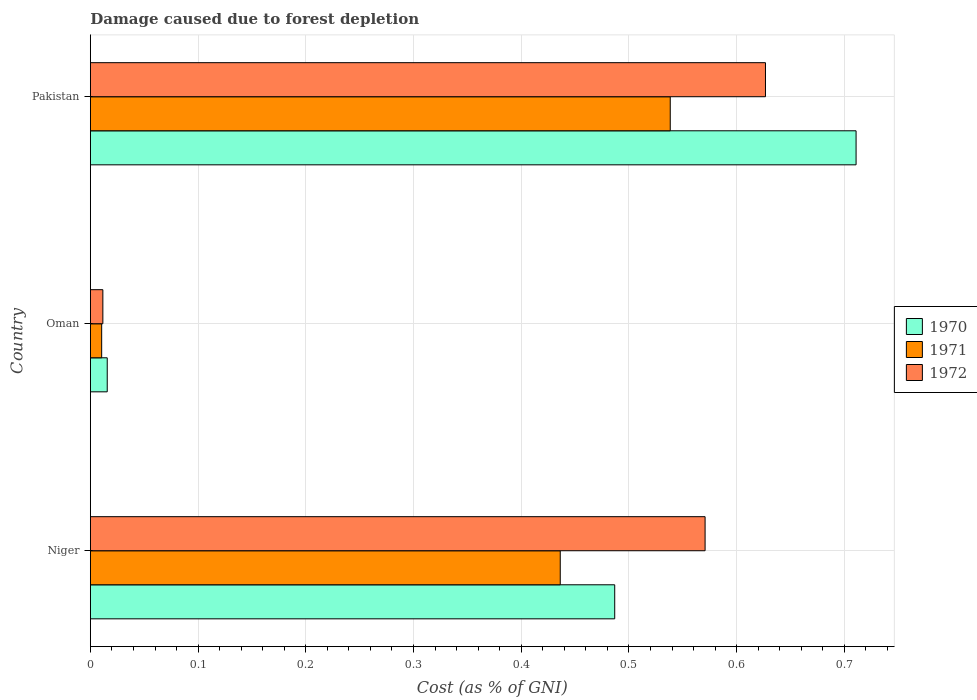Are the number of bars per tick equal to the number of legend labels?
Your answer should be compact. Yes. Are the number of bars on each tick of the Y-axis equal?
Provide a short and direct response. Yes. How many bars are there on the 2nd tick from the top?
Offer a terse response. 3. How many bars are there on the 1st tick from the bottom?
Keep it short and to the point. 3. What is the label of the 3rd group of bars from the top?
Your response must be concise. Niger. What is the cost of damage caused due to forest depletion in 1970 in Oman?
Keep it short and to the point. 0.02. Across all countries, what is the maximum cost of damage caused due to forest depletion in 1971?
Provide a short and direct response. 0.54. Across all countries, what is the minimum cost of damage caused due to forest depletion in 1970?
Ensure brevity in your answer.  0.02. In which country was the cost of damage caused due to forest depletion in 1970 maximum?
Give a very brief answer. Pakistan. In which country was the cost of damage caused due to forest depletion in 1972 minimum?
Offer a very short reply. Oman. What is the total cost of damage caused due to forest depletion in 1972 in the graph?
Provide a short and direct response. 1.21. What is the difference between the cost of damage caused due to forest depletion in 1970 in Niger and that in Oman?
Your answer should be very brief. 0.47. What is the difference between the cost of damage caused due to forest depletion in 1971 in Niger and the cost of damage caused due to forest depletion in 1972 in Oman?
Your response must be concise. 0.42. What is the average cost of damage caused due to forest depletion in 1971 per country?
Offer a very short reply. 0.33. What is the difference between the cost of damage caused due to forest depletion in 1970 and cost of damage caused due to forest depletion in 1972 in Niger?
Your answer should be very brief. -0.08. What is the ratio of the cost of damage caused due to forest depletion in 1970 in Niger to that in Oman?
Offer a terse response. 31.07. What is the difference between the highest and the second highest cost of damage caused due to forest depletion in 1971?
Your answer should be very brief. 0.1. What is the difference between the highest and the lowest cost of damage caused due to forest depletion in 1972?
Make the answer very short. 0.62. Is the sum of the cost of damage caused due to forest depletion in 1970 in Niger and Pakistan greater than the maximum cost of damage caused due to forest depletion in 1972 across all countries?
Provide a short and direct response. Yes. What does the 3rd bar from the top in Niger represents?
Provide a succinct answer. 1970. How many bars are there?
Offer a terse response. 9. What is the difference between two consecutive major ticks on the X-axis?
Keep it short and to the point. 0.1. Are the values on the major ticks of X-axis written in scientific E-notation?
Make the answer very short. No. Where does the legend appear in the graph?
Make the answer very short. Center right. How are the legend labels stacked?
Make the answer very short. Vertical. What is the title of the graph?
Provide a short and direct response. Damage caused due to forest depletion. Does "1961" appear as one of the legend labels in the graph?
Give a very brief answer. No. What is the label or title of the X-axis?
Your answer should be very brief. Cost (as % of GNI). What is the label or title of the Y-axis?
Give a very brief answer. Country. What is the Cost (as % of GNI) of 1970 in Niger?
Ensure brevity in your answer.  0.49. What is the Cost (as % of GNI) in 1971 in Niger?
Provide a short and direct response. 0.44. What is the Cost (as % of GNI) in 1972 in Niger?
Ensure brevity in your answer.  0.57. What is the Cost (as % of GNI) of 1970 in Oman?
Ensure brevity in your answer.  0.02. What is the Cost (as % of GNI) of 1971 in Oman?
Your response must be concise. 0.01. What is the Cost (as % of GNI) of 1972 in Oman?
Give a very brief answer. 0.01. What is the Cost (as % of GNI) in 1970 in Pakistan?
Make the answer very short. 0.71. What is the Cost (as % of GNI) in 1971 in Pakistan?
Provide a succinct answer. 0.54. What is the Cost (as % of GNI) of 1972 in Pakistan?
Offer a very short reply. 0.63. Across all countries, what is the maximum Cost (as % of GNI) in 1970?
Keep it short and to the point. 0.71. Across all countries, what is the maximum Cost (as % of GNI) in 1971?
Make the answer very short. 0.54. Across all countries, what is the maximum Cost (as % of GNI) in 1972?
Provide a succinct answer. 0.63. Across all countries, what is the minimum Cost (as % of GNI) in 1970?
Offer a very short reply. 0.02. Across all countries, what is the minimum Cost (as % of GNI) of 1971?
Ensure brevity in your answer.  0.01. Across all countries, what is the minimum Cost (as % of GNI) of 1972?
Offer a very short reply. 0.01. What is the total Cost (as % of GNI) of 1970 in the graph?
Your answer should be very brief. 1.21. What is the total Cost (as % of GNI) of 1972 in the graph?
Ensure brevity in your answer.  1.21. What is the difference between the Cost (as % of GNI) of 1970 in Niger and that in Oman?
Provide a succinct answer. 0.47. What is the difference between the Cost (as % of GNI) of 1971 in Niger and that in Oman?
Your response must be concise. 0.43. What is the difference between the Cost (as % of GNI) in 1972 in Niger and that in Oman?
Make the answer very short. 0.56. What is the difference between the Cost (as % of GNI) of 1970 in Niger and that in Pakistan?
Your answer should be very brief. -0.22. What is the difference between the Cost (as % of GNI) of 1971 in Niger and that in Pakistan?
Give a very brief answer. -0.1. What is the difference between the Cost (as % of GNI) of 1972 in Niger and that in Pakistan?
Ensure brevity in your answer.  -0.06. What is the difference between the Cost (as % of GNI) in 1970 in Oman and that in Pakistan?
Provide a succinct answer. -0.7. What is the difference between the Cost (as % of GNI) of 1971 in Oman and that in Pakistan?
Ensure brevity in your answer.  -0.53. What is the difference between the Cost (as % of GNI) in 1972 in Oman and that in Pakistan?
Offer a very short reply. -0.62. What is the difference between the Cost (as % of GNI) in 1970 in Niger and the Cost (as % of GNI) in 1971 in Oman?
Provide a succinct answer. 0.48. What is the difference between the Cost (as % of GNI) of 1970 in Niger and the Cost (as % of GNI) of 1972 in Oman?
Ensure brevity in your answer.  0.48. What is the difference between the Cost (as % of GNI) of 1971 in Niger and the Cost (as % of GNI) of 1972 in Oman?
Your answer should be very brief. 0.42. What is the difference between the Cost (as % of GNI) in 1970 in Niger and the Cost (as % of GNI) in 1971 in Pakistan?
Give a very brief answer. -0.05. What is the difference between the Cost (as % of GNI) in 1970 in Niger and the Cost (as % of GNI) in 1972 in Pakistan?
Your answer should be compact. -0.14. What is the difference between the Cost (as % of GNI) of 1971 in Niger and the Cost (as % of GNI) of 1972 in Pakistan?
Offer a very short reply. -0.19. What is the difference between the Cost (as % of GNI) in 1970 in Oman and the Cost (as % of GNI) in 1971 in Pakistan?
Provide a short and direct response. -0.52. What is the difference between the Cost (as % of GNI) of 1970 in Oman and the Cost (as % of GNI) of 1972 in Pakistan?
Provide a succinct answer. -0.61. What is the difference between the Cost (as % of GNI) in 1971 in Oman and the Cost (as % of GNI) in 1972 in Pakistan?
Give a very brief answer. -0.62. What is the average Cost (as % of GNI) in 1970 per country?
Your answer should be compact. 0.4. What is the average Cost (as % of GNI) of 1971 per country?
Provide a succinct answer. 0.33. What is the average Cost (as % of GNI) of 1972 per country?
Offer a very short reply. 0.4. What is the difference between the Cost (as % of GNI) of 1970 and Cost (as % of GNI) of 1971 in Niger?
Keep it short and to the point. 0.05. What is the difference between the Cost (as % of GNI) of 1970 and Cost (as % of GNI) of 1972 in Niger?
Offer a very short reply. -0.08. What is the difference between the Cost (as % of GNI) in 1971 and Cost (as % of GNI) in 1972 in Niger?
Keep it short and to the point. -0.13. What is the difference between the Cost (as % of GNI) in 1970 and Cost (as % of GNI) in 1971 in Oman?
Provide a succinct answer. 0.01. What is the difference between the Cost (as % of GNI) of 1970 and Cost (as % of GNI) of 1972 in Oman?
Your answer should be compact. 0. What is the difference between the Cost (as % of GNI) of 1971 and Cost (as % of GNI) of 1972 in Oman?
Ensure brevity in your answer.  -0. What is the difference between the Cost (as % of GNI) in 1970 and Cost (as % of GNI) in 1971 in Pakistan?
Make the answer very short. 0.17. What is the difference between the Cost (as % of GNI) in 1970 and Cost (as % of GNI) in 1972 in Pakistan?
Your answer should be compact. 0.08. What is the difference between the Cost (as % of GNI) in 1971 and Cost (as % of GNI) in 1972 in Pakistan?
Offer a terse response. -0.09. What is the ratio of the Cost (as % of GNI) in 1970 in Niger to that in Oman?
Your response must be concise. 31.07. What is the ratio of the Cost (as % of GNI) in 1971 in Niger to that in Oman?
Provide a short and direct response. 41.58. What is the ratio of the Cost (as % of GNI) in 1972 in Niger to that in Oman?
Your response must be concise. 49.18. What is the ratio of the Cost (as % of GNI) in 1970 in Niger to that in Pakistan?
Provide a short and direct response. 0.68. What is the ratio of the Cost (as % of GNI) of 1971 in Niger to that in Pakistan?
Give a very brief answer. 0.81. What is the ratio of the Cost (as % of GNI) in 1972 in Niger to that in Pakistan?
Keep it short and to the point. 0.91. What is the ratio of the Cost (as % of GNI) of 1970 in Oman to that in Pakistan?
Keep it short and to the point. 0.02. What is the ratio of the Cost (as % of GNI) of 1971 in Oman to that in Pakistan?
Your response must be concise. 0.02. What is the ratio of the Cost (as % of GNI) of 1972 in Oman to that in Pakistan?
Give a very brief answer. 0.02. What is the difference between the highest and the second highest Cost (as % of GNI) in 1970?
Give a very brief answer. 0.22. What is the difference between the highest and the second highest Cost (as % of GNI) of 1971?
Keep it short and to the point. 0.1. What is the difference between the highest and the second highest Cost (as % of GNI) in 1972?
Give a very brief answer. 0.06. What is the difference between the highest and the lowest Cost (as % of GNI) in 1970?
Your answer should be compact. 0.7. What is the difference between the highest and the lowest Cost (as % of GNI) of 1971?
Your response must be concise. 0.53. What is the difference between the highest and the lowest Cost (as % of GNI) of 1972?
Your answer should be compact. 0.62. 